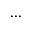Convert formula to latex. <formula><loc_0><loc_0><loc_500><loc_500>\dots</formula> 